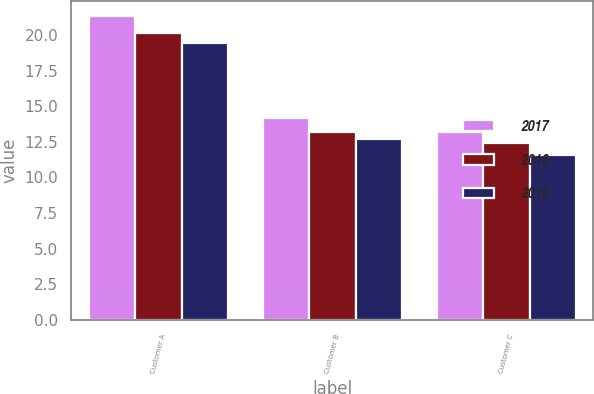Convert chart to OTSL. <chart><loc_0><loc_0><loc_500><loc_500><stacked_bar_chart><ecel><fcel>Customer A<fcel>Customer B<fcel>Customer C<nl><fcel>2017<fcel>21.3<fcel>14.2<fcel>13.2<nl><fcel>2016<fcel>20.1<fcel>13.2<fcel>12.4<nl><fcel>2015<fcel>19.4<fcel>12.7<fcel>11.6<nl></chart> 